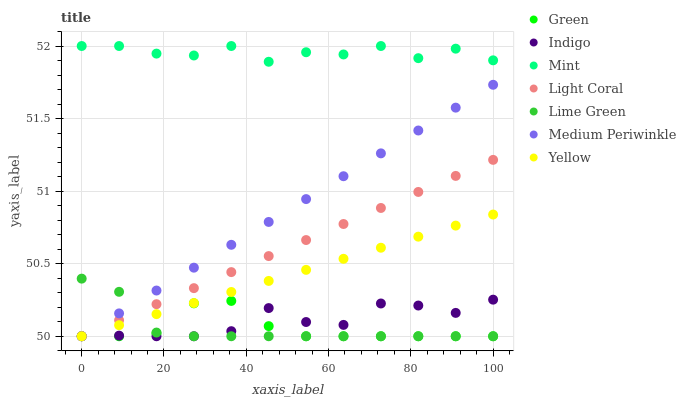Does Lime Green have the minimum area under the curve?
Answer yes or no. Yes. Does Mint have the maximum area under the curve?
Answer yes or no. Yes. Does Medium Periwinkle have the minimum area under the curve?
Answer yes or no. No. Does Medium Periwinkle have the maximum area under the curve?
Answer yes or no. No. Is Light Coral the smoothest?
Answer yes or no. Yes. Is Mint the roughest?
Answer yes or no. Yes. Is Lime Green the smoothest?
Answer yes or no. No. Is Lime Green the roughest?
Answer yes or no. No. Does Indigo have the lowest value?
Answer yes or no. Yes. Does Mint have the lowest value?
Answer yes or no. No. Does Mint have the highest value?
Answer yes or no. Yes. Does Lime Green have the highest value?
Answer yes or no. No. Is Green less than Mint?
Answer yes or no. Yes. Is Mint greater than Lime Green?
Answer yes or no. Yes. Does Light Coral intersect Lime Green?
Answer yes or no. Yes. Is Light Coral less than Lime Green?
Answer yes or no. No. Is Light Coral greater than Lime Green?
Answer yes or no. No. Does Green intersect Mint?
Answer yes or no. No. 